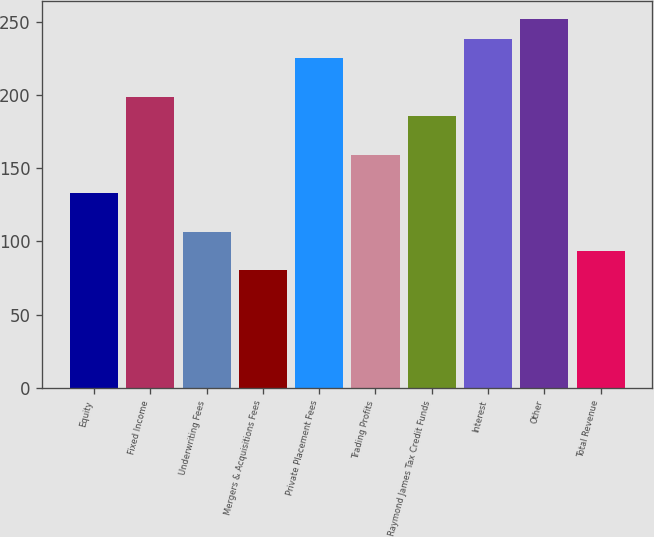<chart> <loc_0><loc_0><loc_500><loc_500><bar_chart><fcel>Equity<fcel>Fixed Income<fcel>Underwriting Fees<fcel>Mergers & Acquisitions Fees<fcel>Private Placement Fees<fcel>Trading Profits<fcel>Raymond James Tax Credit Funds<fcel>Interest<fcel>Other<fcel>Total Revenue<nl><fcel>133<fcel>199<fcel>106.6<fcel>80.2<fcel>225.4<fcel>159.4<fcel>185.8<fcel>238.6<fcel>251.8<fcel>93.4<nl></chart> 